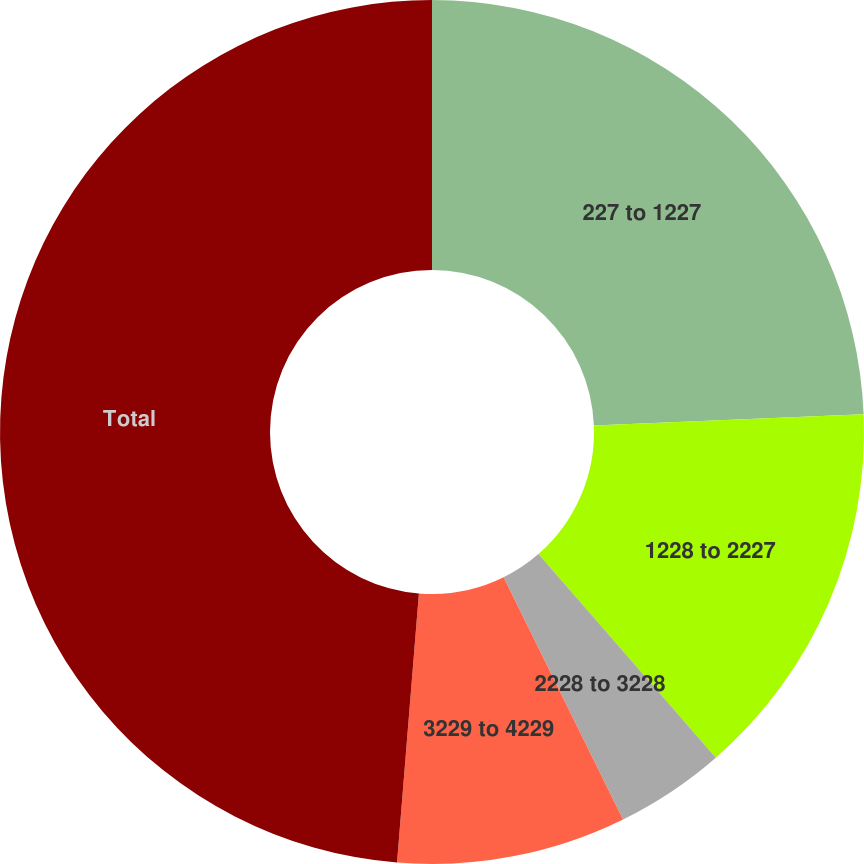Convert chart to OTSL. <chart><loc_0><loc_0><loc_500><loc_500><pie_chart><fcel>227 to 1227<fcel>1228 to 2227<fcel>2228 to 3228<fcel>3229 to 4229<fcel>Total<nl><fcel>24.35%<fcel>14.24%<fcel>4.12%<fcel>8.58%<fcel>48.71%<nl></chart> 